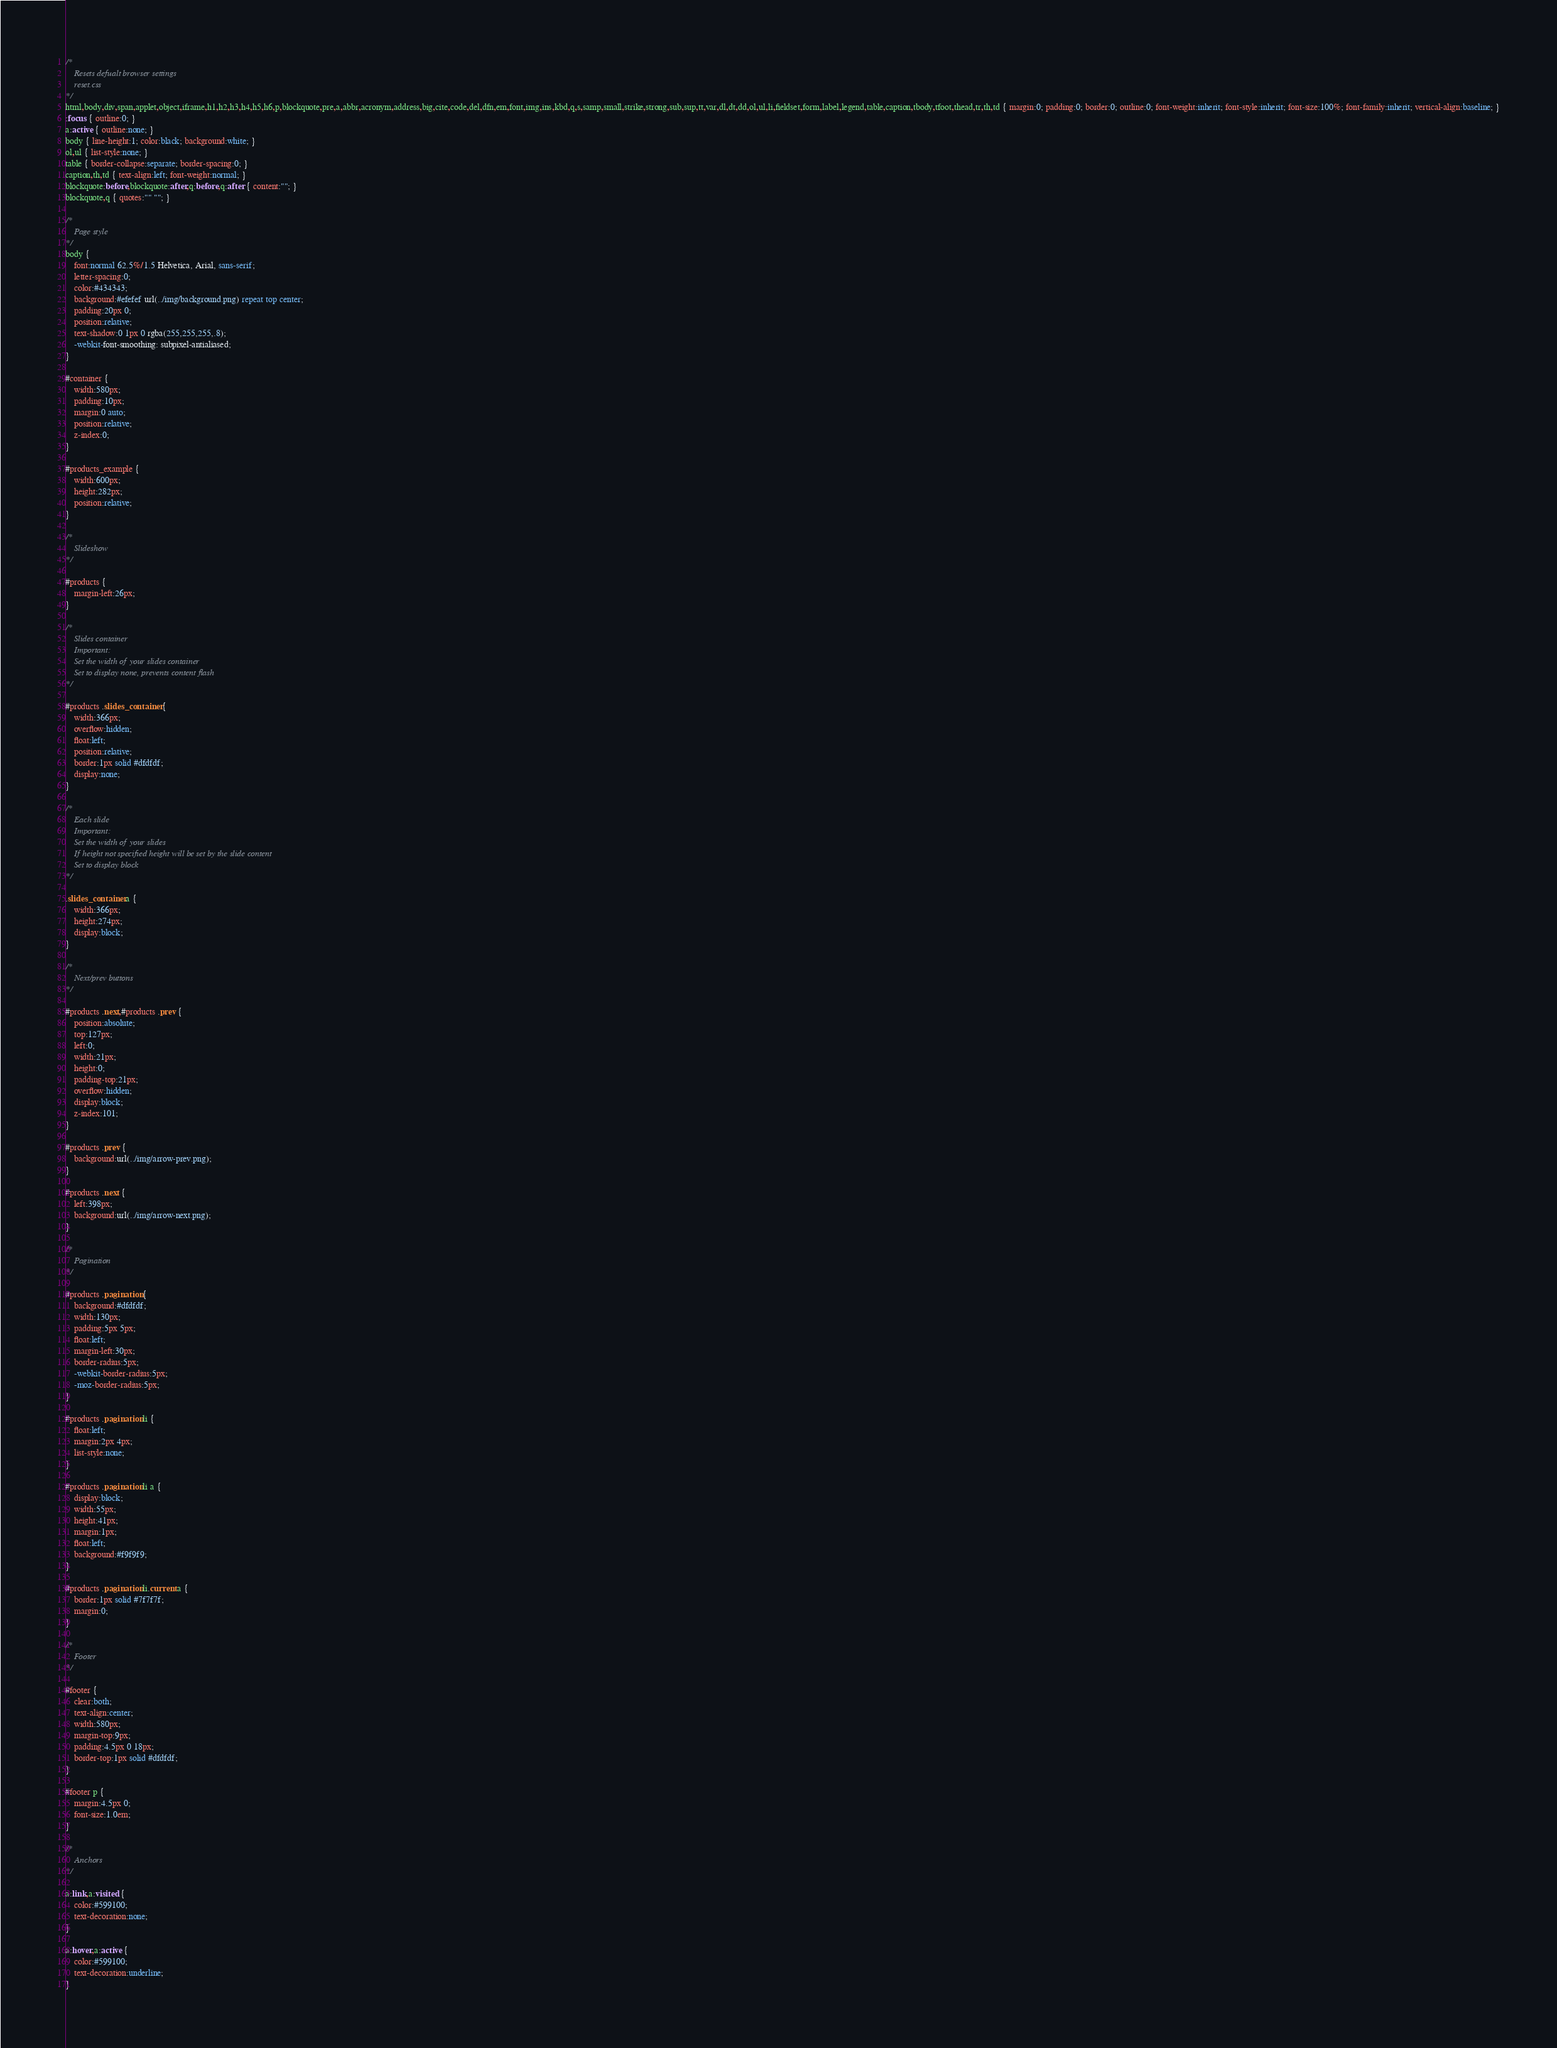Convert code to text. <code><loc_0><loc_0><loc_500><loc_500><_CSS_>/* 
	Resets defualt browser settings
	reset.css
*/
html,body,div,span,applet,object,iframe,h1,h2,h3,h4,h5,h6,p,blockquote,pre,a,abbr,acronym,address,big,cite,code,del,dfn,em,font,img,ins,kbd,q,s,samp,small,strike,strong,sub,sup,tt,var,dl,dt,dd,ol,ul,li,fieldset,form,label,legend,table,caption,tbody,tfoot,thead,tr,th,td { margin:0; padding:0; border:0; outline:0; font-weight:inherit; font-style:inherit; font-size:100%; font-family:inherit; vertical-align:baseline; }
:focus { outline:0; }
a:active { outline:none; }
body { line-height:1; color:black; background:white; }
ol,ul { list-style:none; }
table { border-collapse:separate; border-spacing:0; }
caption,th,td { text-align:left; font-weight:normal; }
blockquote:before,blockquote:after,q:before,q:after { content:""; }
blockquote,q { quotes:"" ""; }

/*
	Page style
*/
body { 
	font:normal 62.5%/1.5 Helvetica, Arial, sans-serif;
	letter-spacing:0;
	color:#434343;
	background:#efefef url(../img/background.png) repeat top center;
	padding:20px 0;
	position:relative;
	text-shadow:0 1px 0 rgba(255,255,255,.8);
	-webkit-font-smoothing: subpixel-antialiased;
}

#container {
	width:580px;
	padding:10px;
	margin:0 auto;
	position:relative;
	z-index:0;
}

#products_example {
	width:600px;
	height:282px;
	position:relative;
}

/*
	Slideshow
*/

#products {
	margin-left:26px;
}

/*
	Slides container
	Important:
	Set the width of your slides container
	Set to display none, prevents content flash
*/

#products .slides_container {
	width:366px;
	overflow:hidden;
	float:left;
	position:relative;
	border:1px solid #dfdfdf;
	display:none;
}

/*
	Each slide
	Important:
	Set the width of your slides
	If height not specified height will be set by the slide content
	Set to display block
*/

.slides_container a {
	width:366px;
	height:274px;
	display:block;
}

/*
	Next/prev buttons
*/

#products .next,#products .prev {
	position:absolute;
	top:127px;
	left:0;
	width:21px;
	height:0;
	padding-top:21px;
	overflow:hidden;
	display:block;
	z-index:101;
}

#products .prev {
	background:url(../img/arrow-prev.png);
}

#products .next {
	left:398px;
	background:url(../img/arrow-next.png);
}

/*
	Pagination
*/

#products .pagination {
	background:#dfdfdf;
	width:130px;
	padding:5px 5px;
	float:left;
	margin-left:30px;
	border-radius:5px;
	-webkit-border-radius:5px;
	-moz-border-radius:5px;
}

#products .pagination li {
	float:left;
	margin:2px 4px;
	list-style:none;
}

#products .pagination li a {
	display:block;
	width:55px;
	height:41px;
	margin:1px;
	float:left;
	background:#f9f9f9;
}

#products .pagination li.current a {
	border:1px solid #7f7f7f;
	margin:0;
}

/*
	Footer
*/

#footer {
	clear:both;
	text-align:center;
	width:580px;
	margin-top:9px;
	padding:4.5px 0 18px;
	border-top:1px solid #dfdfdf;
}

#footer p {
	margin:4.5px 0;
	font-size:1.0em;
}

/*
	Anchors
*/

a:link,a:visited {
	color:#599100;
	text-decoration:none;
}

a:hover,a:active {
	color:#599100;
	text-decoration:underline;
}</code> 